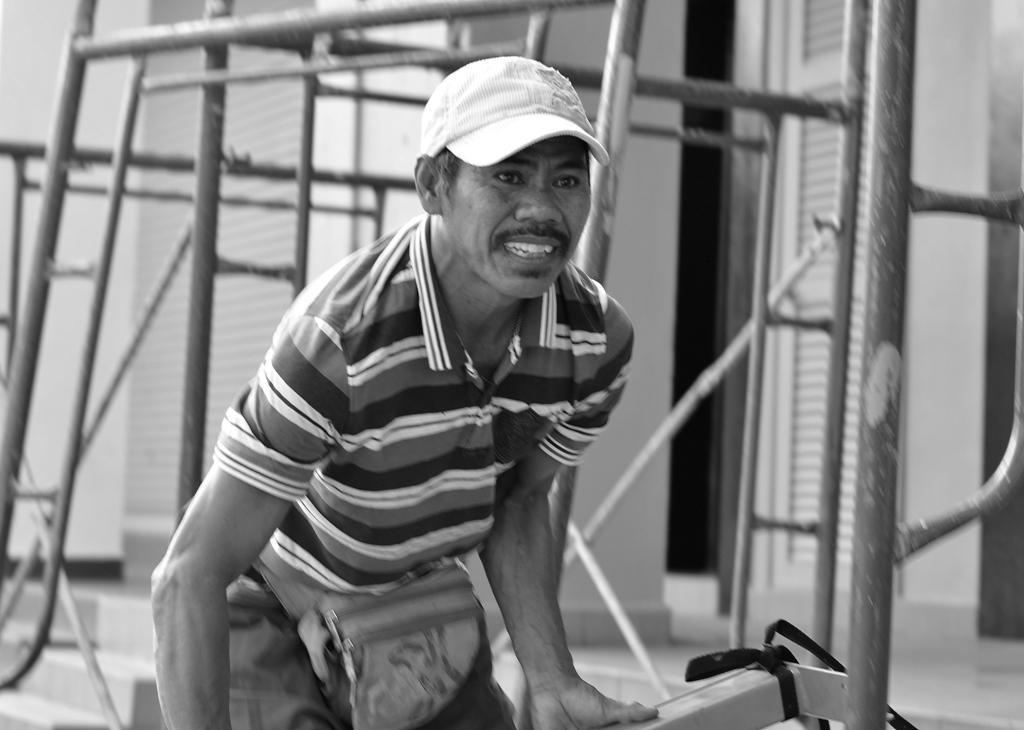In one or two sentences, can you explain what this image depicts? In this image, we can see a man standing and he is holding an object, he is wearing a hat. 